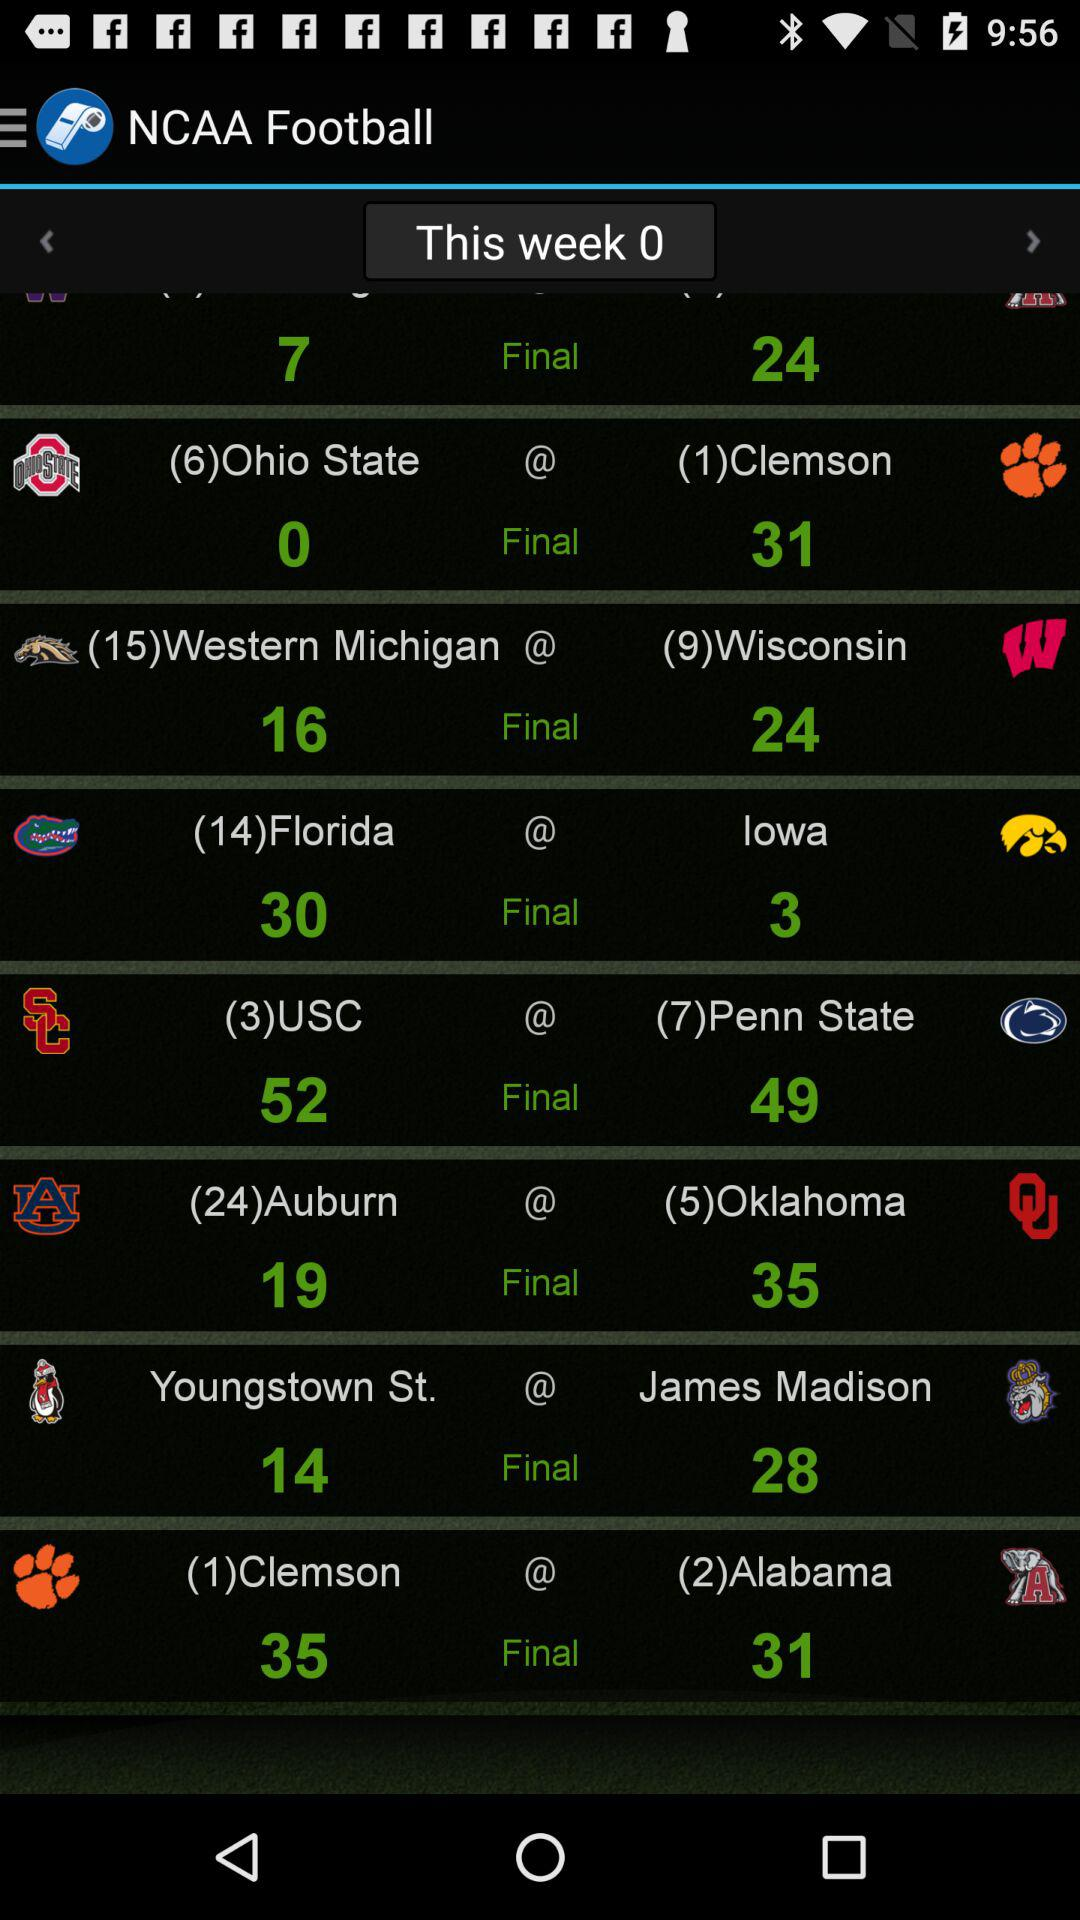What is the name of the application? The name of the application is "NCAA Football". 